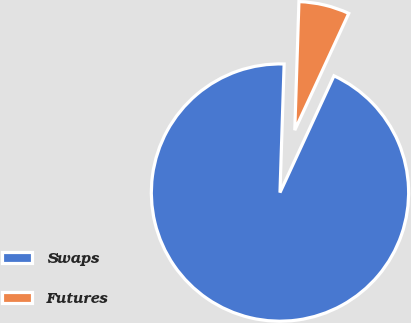Convert chart to OTSL. <chart><loc_0><loc_0><loc_500><loc_500><pie_chart><fcel>Swaps<fcel>Futures<nl><fcel>93.62%<fcel>6.38%<nl></chart> 